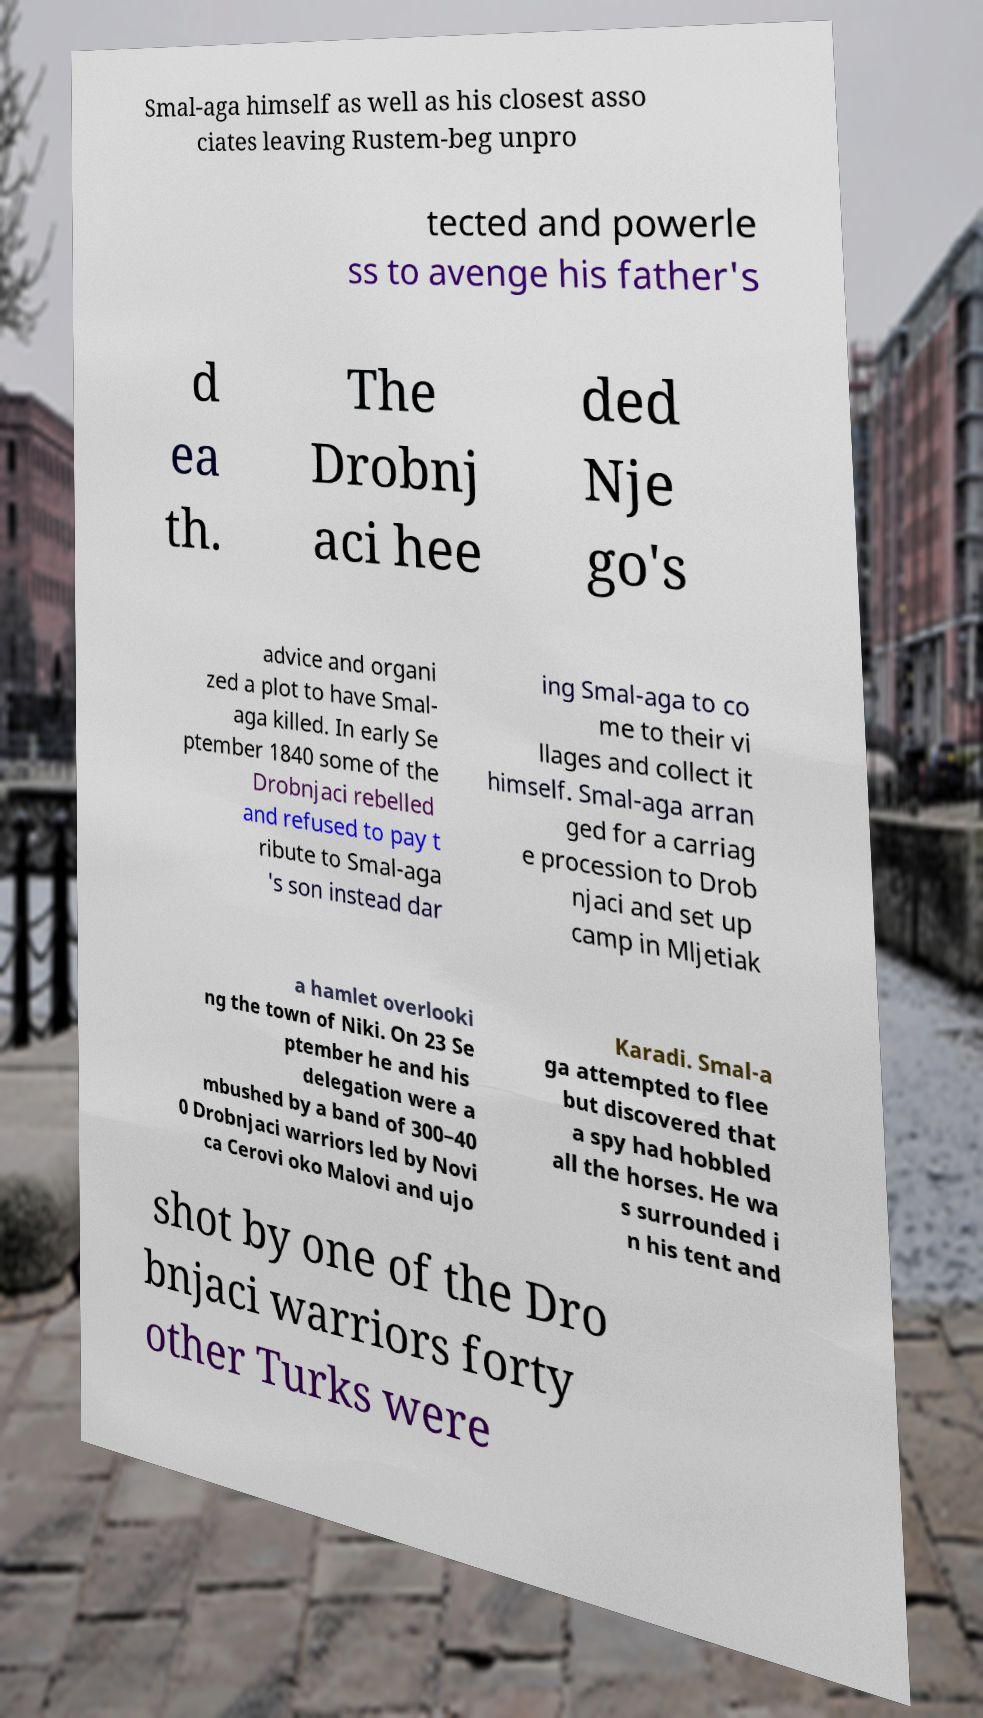There's text embedded in this image that I need extracted. Can you transcribe it verbatim? Smal-aga himself as well as his closest asso ciates leaving Rustem-beg unpro tected and powerle ss to avenge his father's d ea th. The Drobnj aci hee ded Nje go's advice and organi zed a plot to have Smal- aga killed. In early Se ptember 1840 some of the Drobnjaci rebelled and refused to pay t ribute to Smal-aga 's son instead dar ing Smal-aga to co me to their vi llages and collect it himself. Smal-aga arran ged for a carriag e procession to Drob njaci and set up camp in Mljetiak a hamlet overlooki ng the town of Niki. On 23 Se ptember he and his delegation were a mbushed by a band of 300–40 0 Drobnjaci warriors led by Novi ca Cerovi oko Malovi and ujo Karadi. Smal-a ga attempted to flee but discovered that a spy had hobbled all the horses. He wa s surrounded i n his tent and shot by one of the Dro bnjaci warriors forty other Turks were 